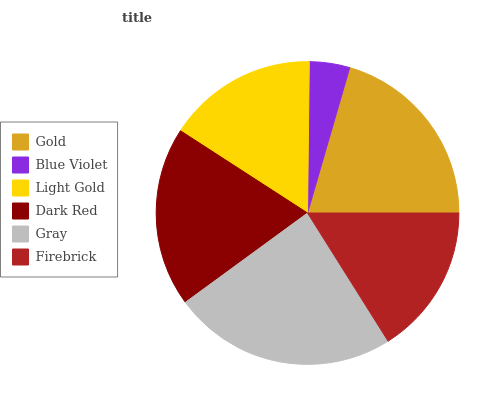Is Blue Violet the minimum?
Answer yes or no. Yes. Is Gray the maximum?
Answer yes or no. Yes. Is Light Gold the minimum?
Answer yes or no. No. Is Light Gold the maximum?
Answer yes or no. No. Is Light Gold greater than Blue Violet?
Answer yes or no. Yes. Is Blue Violet less than Light Gold?
Answer yes or no. Yes. Is Blue Violet greater than Light Gold?
Answer yes or no. No. Is Light Gold less than Blue Violet?
Answer yes or no. No. Is Dark Red the high median?
Answer yes or no. Yes. Is Firebrick the low median?
Answer yes or no. Yes. Is Gray the high median?
Answer yes or no. No. Is Gold the low median?
Answer yes or no. No. 